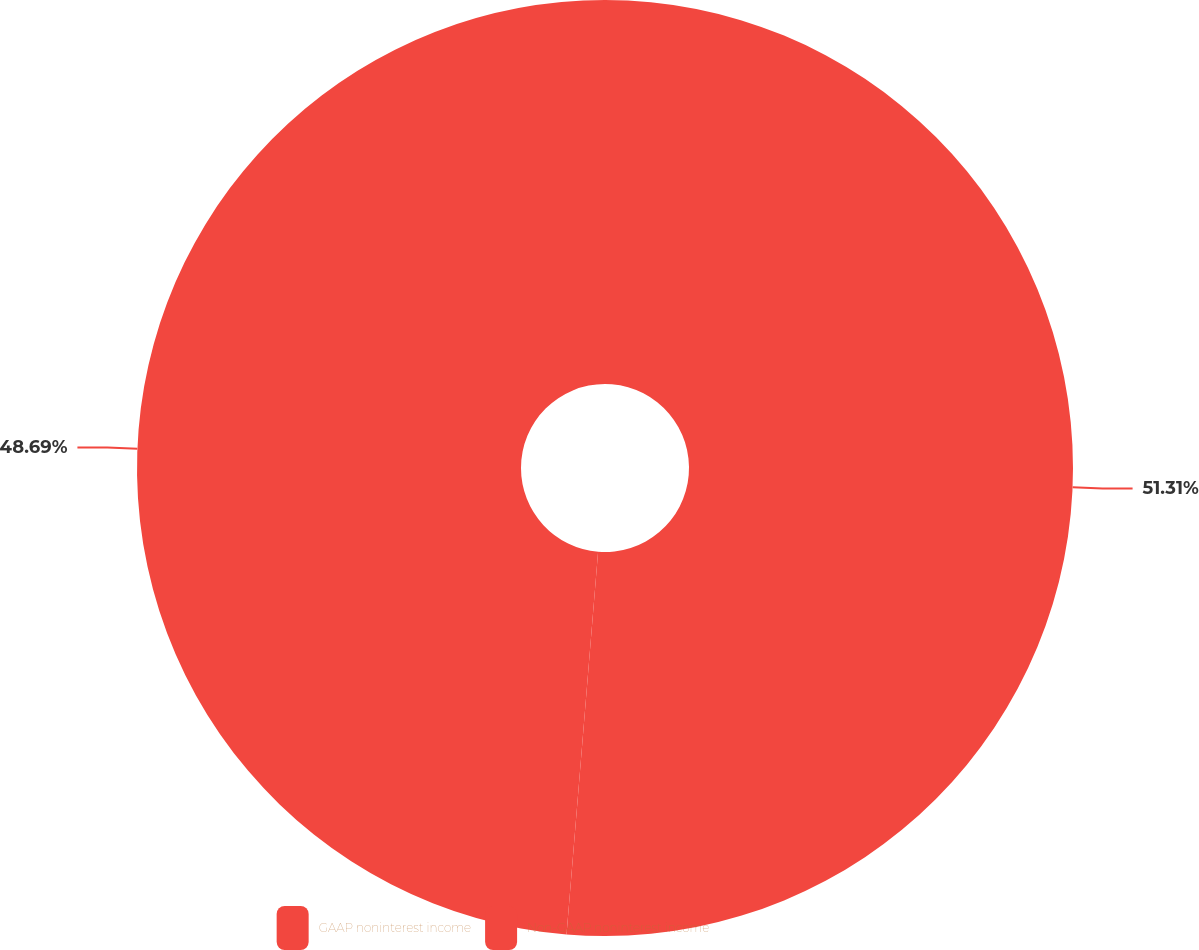<chart> <loc_0><loc_0><loc_500><loc_500><pie_chart><fcel>GAAP noninterest income<fcel>Non-GAAP noninterest income<nl><fcel>51.31%<fcel>48.69%<nl></chart> 